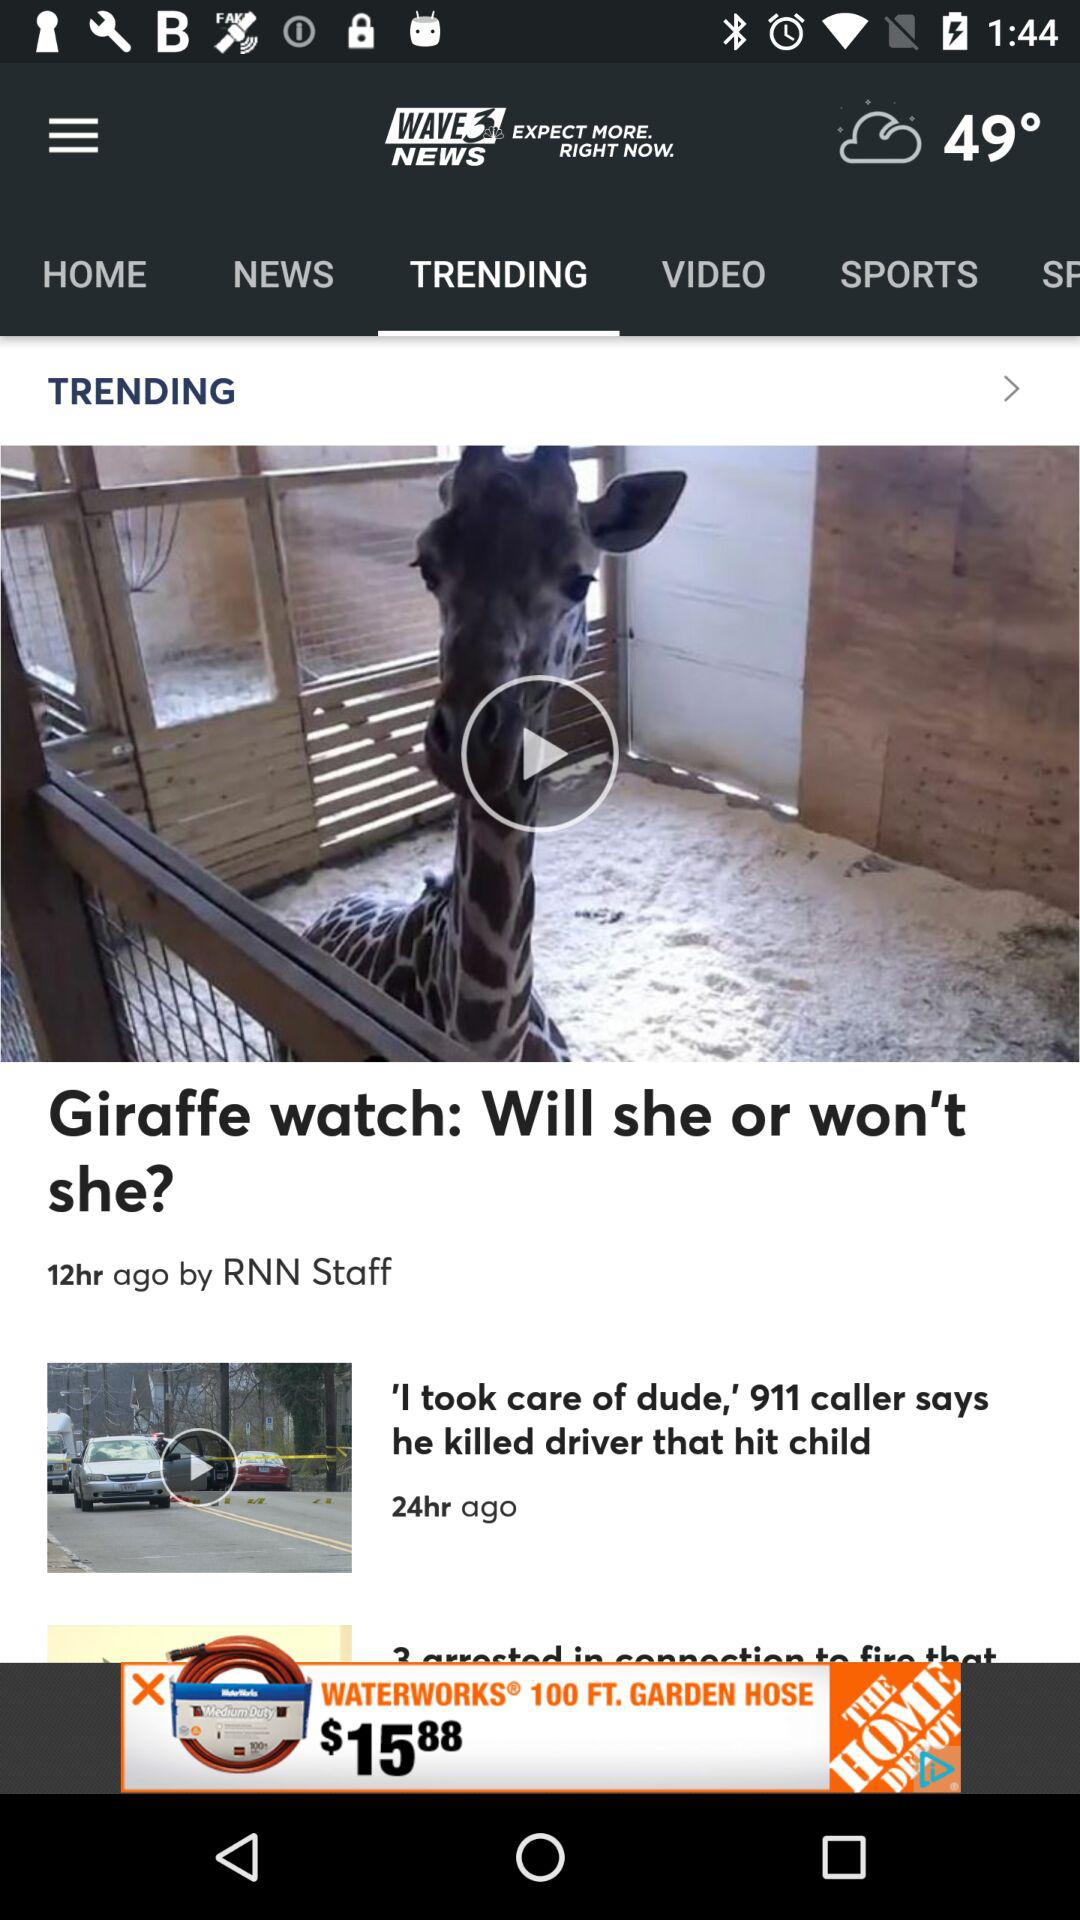What is the name of the trending video which was published 24 hours ago? The name of the trending video that was published 24 hours ago is "'I took care of dude,' 911 caller says he killed driver that hit child". 